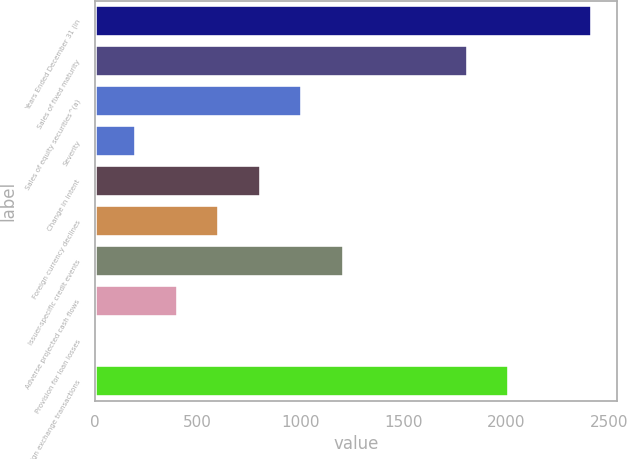Convert chart to OTSL. <chart><loc_0><loc_0><loc_500><loc_500><bar_chart><fcel>Years Ended December 31 (in<fcel>Sales of fixed maturity<fcel>Sales of equity securities^(a)<fcel>Severity<fcel>Change in intent<fcel>Foreign currency declines<fcel>Issuer-specific credit events<fcel>Adverse projected cash flows<fcel>Provision for loan losses<fcel>Foreign exchange transactions<nl><fcel>2416.6<fcel>1812.7<fcel>1007.5<fcel>202.3<fcel>806.2<fcel>604.9<fcel>1208.8<fcel>403.6<fcel>1<fcel>2014<nl></chart> 